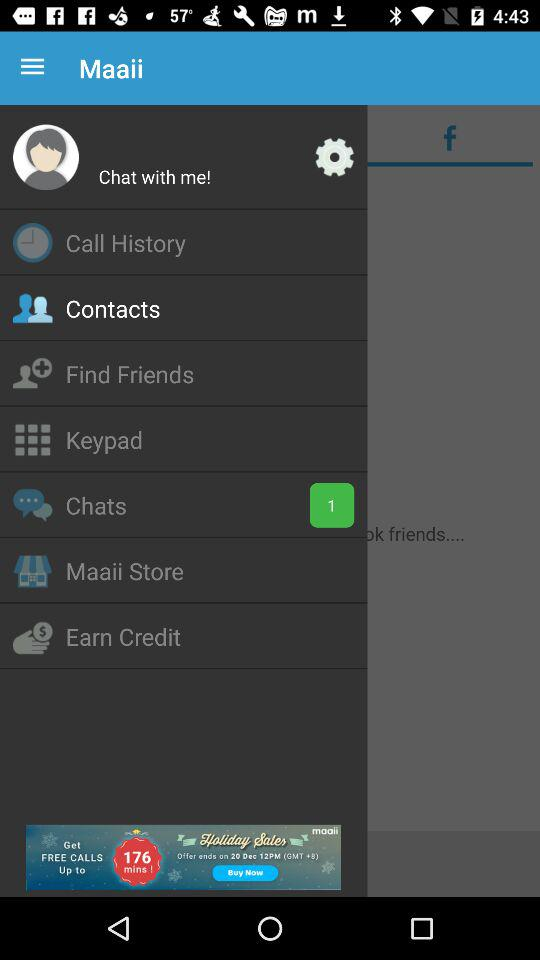What is the number of unread chats? There is 1 unread chat. 